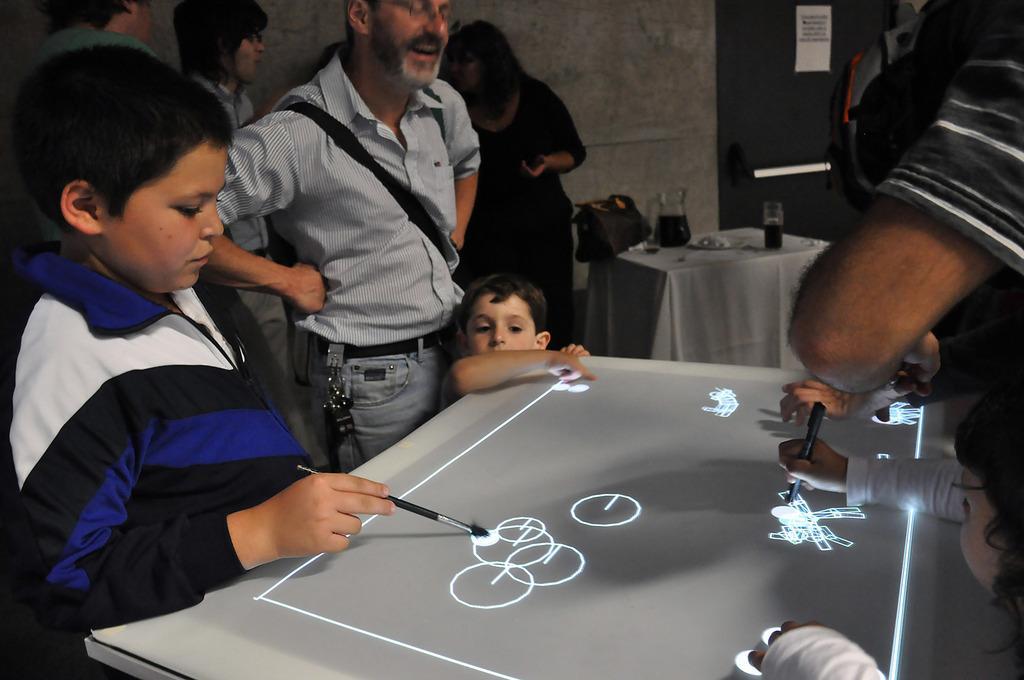Describe this image in one or two sentences. In this image we can see the board on which we can see LED lights making pictures. Here we can see this child is standing and holding a brush in his hands and this child is holding a pen. Also, we can see these people standing near the table. In the background, we can see a table on which we can see jar and glasses with drink and a bag on it. Also, we can see the wall and the door on which we can see a paper. 